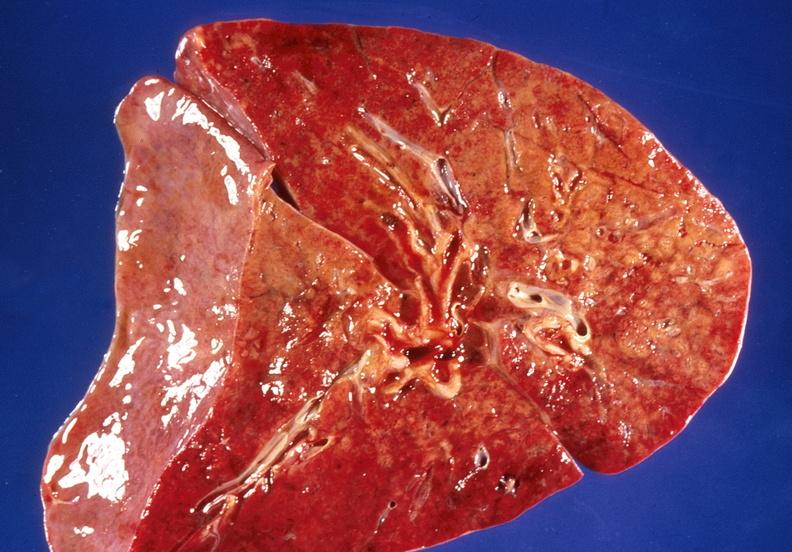where is this?
Answer the question using a single word or phrase. Lung 